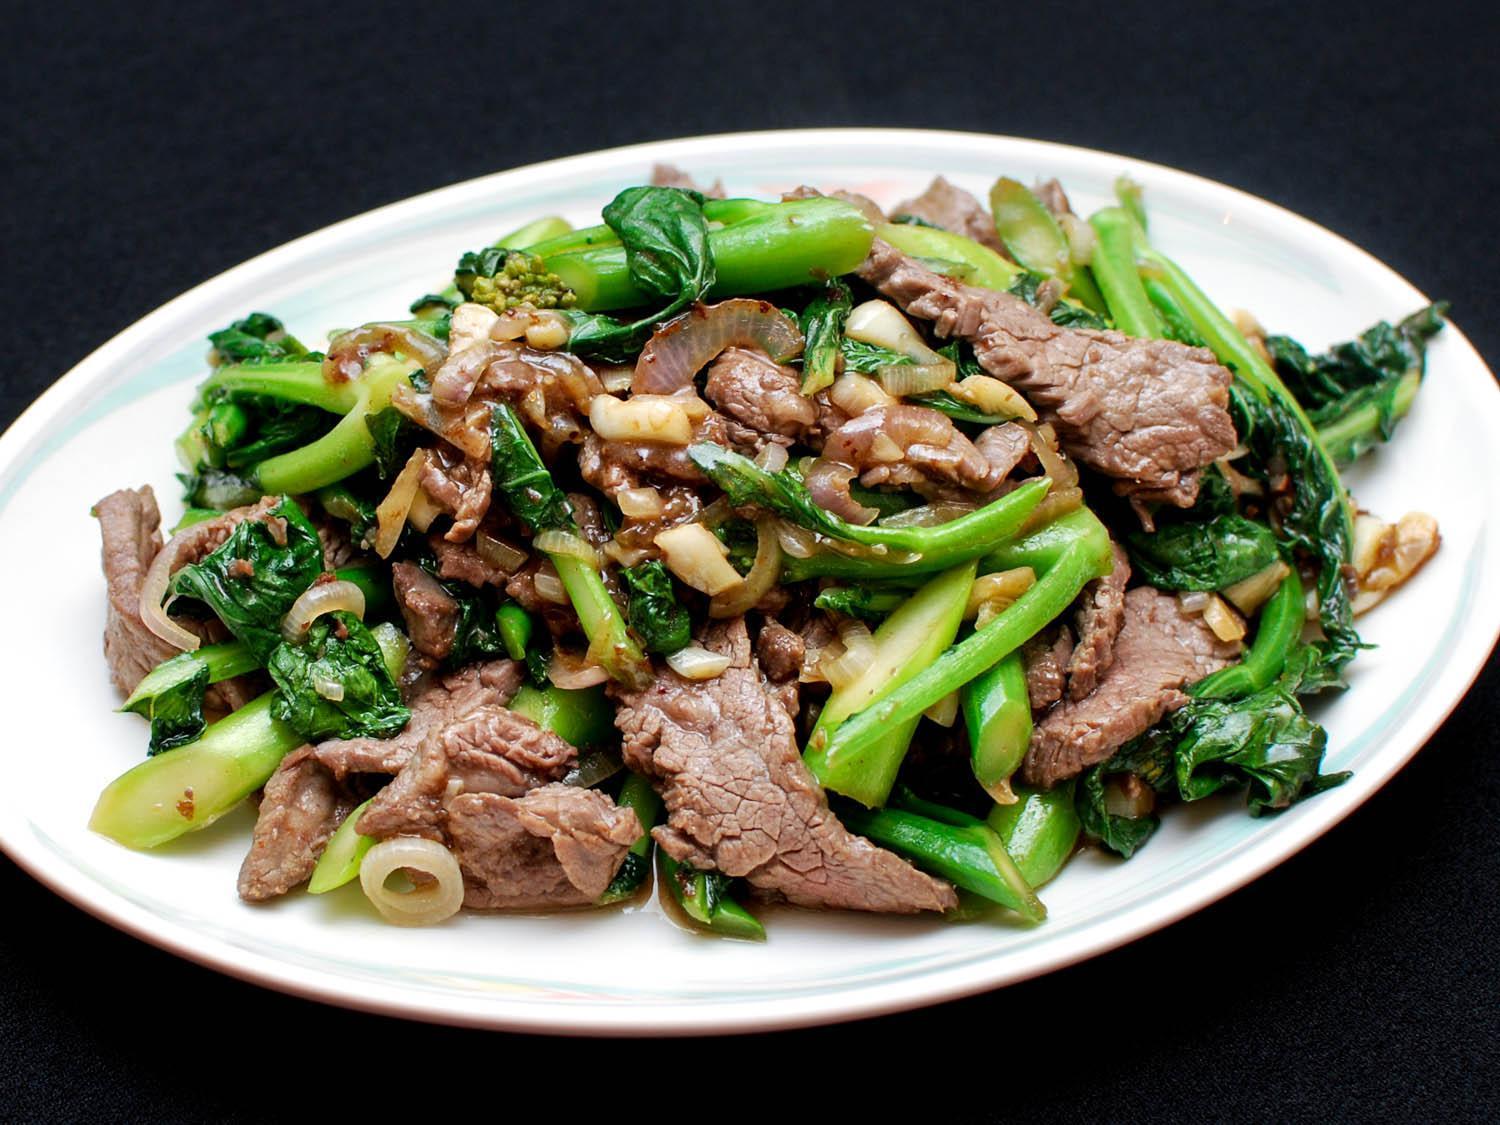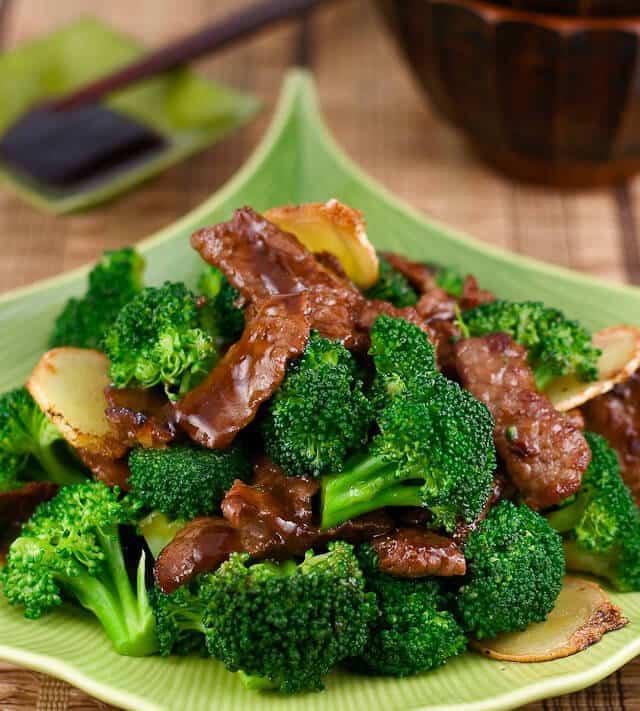The first image is the image on the left, the second image is the image on the right. For the images shown, is this caption "The food in the image on the right is being served in a white dish." true? Answer yes or no. No. The first image is the image on the left, the second image is the image on the right. Given the left and right images, does the statement "Right image shows a white plate containing an entree that includes white rice and broccoli." hold true? Answer yes or no. No. 